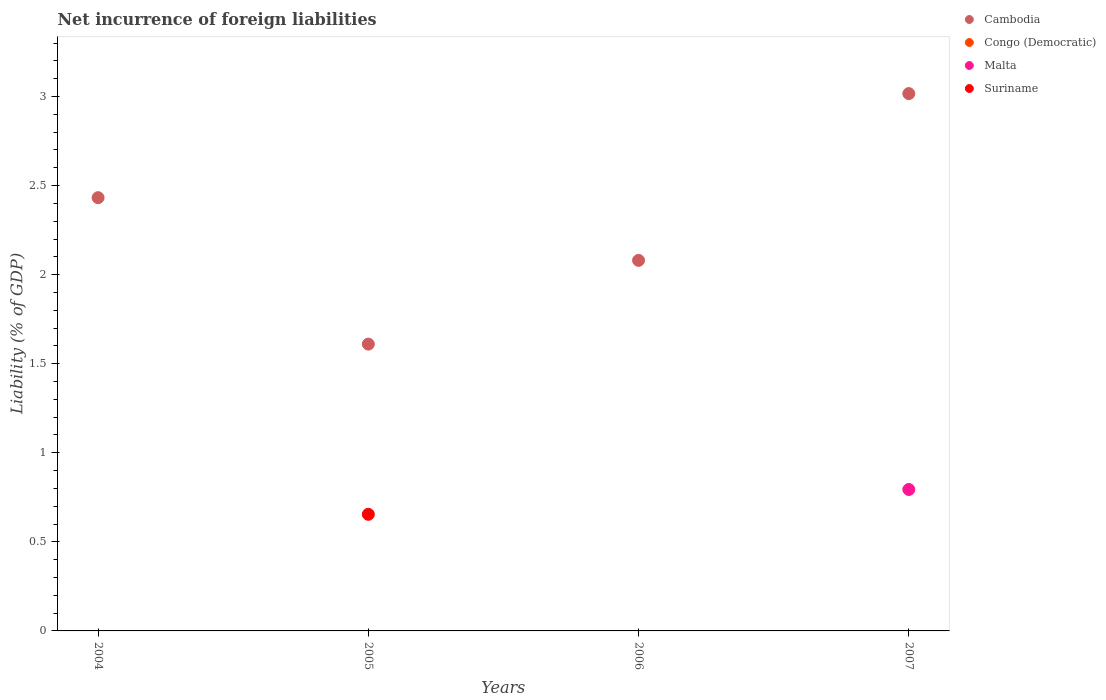What is the net incurrence of foreign liabilities in Cambodia in 2006?
Your answer should be very brief. 2.08. Across all years, what is the maximum net incurrence of foreign liabilities in Cambodia?
Give a very brief answer. 3.02. Across all years, what is the minimum net incurrence of foreign liabilities in Malta?
Give a very brief answer. 0. What is the total net incurrence of foreign liabilities in Suriname in the graph?
Ensure brevity in your answer.  0.65. What is the difference between the net incurrence of foreign liabilities in Cambodia in 2004 and that in 2007?
Your answer should be very brief. -0.58. What is the average net incurrence of foreign liabilities in Cambodia per year?
Make the answer very short. 2.28. In the year 2005, what is the difference between the net incurrence of foreign liabilities in Cambodia and net incurrence of foreign liabilities in Suriname?
Make the answer very short. 0.96. In how many years, is the net incurrence of foreign liabilities in Cambodia greater than 1 %?
Offer a very short reply. 4. What is the ratio of the net incurrence of foreign liabilities in Cambodia in 2004 to that in 2005?
Offer a terse response. 1.51. Is the net incurrence of foreign liabilities in Cambodia in 2005 less than that in 2007?
Give a very brief answer. Yes. What is the difference between the highest and the lowest net incurrence of foreign liabilities in Suriname?
Keep it short and to the point. 0.65. In how many years, is the net incurrence of foreign liabilities in Malta greater than the average net incurrence of foreign liabilities in Malta taken over all years?
Provide a succinct answer. 1. Is it the case that in every year, the sum of the net incurrence of foreign liabilities in Malta and net incurrence of foreign liabilities in Congo (Democratic)  is greater than the sum of net incurrence of foreign liabilities in Suriname and net incurrence of foreign liabilities in Cambodia?
Your answer should be compact. No. Is it the case that in every year, the sum of the net incurrence of foreign liabilities in Cambodia and net incurrence of foreign liabilities in Malta  is greater than the net incurrence of foreign liabilities in Suriname?
Keep it short and to the point. Yes. Is the net incurrence of foreign liabilities in Malta strictly greater than the net incurrence of foreign liabilities in Suriname over the years?
Offer a terse response. No. Is the net incurrence of foreign liabilities in Congo (Democratic) strictly less than the net incurrence of foreign liabilities in Suriname over the years?
Offer a terse response. No. What is the difference between two consecutive major ticks on the Y-axis?
Ensure brevity in your answer.  0.5. Does the graph contain grids?
Your answer should be very brief. No. How are the legend labels stacked?
Offer a very short reply. Vertical. What is the title of the graph?
Offer a very short reply. Net incurrence of foreign liabilities. What is the label or title of the Y-axis?
Give a very brief answer. Liability (% of GDP). What is the Liability (% of GDP) in Cambodia in 2004?
Provide a short and direct response. 2.43. What is the Liability (% of GDP) of Congo (Democratic) in 2004?
Keep it short and to the point. 0. What is the Liability (% of GDP) in Cambodia in 2005?
Keep it short and to the point. 1.61. What is the Liability (% of GDP) in Malta in 2005?
Keep it short and to the point. 0. What is the Liability (% of GDP) in Suriname in 2005?
Your answer should be compact. 0.65. What is the Liability (% of GDP) in Cambodia in 2006?
Provide a short and direct response. 2.08. What is the Liability (% of GDP) in Congo (Democratic) in 2006?
Your answer should be compact. 0. What is the Liability (% of GDP) in Cambodia in 2007?
Provide a succinct answer. 3.02. What is the Liability (% of GDP) of Congo (Democratic) in 2007?
Make the answer very short. 0. What is the Liability (% of GDP) of Malta in 2007?
Offer a terse response. 0.79. What is the Liability (% of GDP) of Suriname in 2007?
Your answer should be very brief. 0. Across all years, what is the maximum Liability (% of GDP) of Cambodia?
Ensure brevity in your answer.  3.02. Across all years, what is the maximum Liability (% of GDP) of Malta?
Make the answer very short. 0.79. Across all years, what is the maximum Liability (% of GDP) in Suriname?
Offer a terse response. 0.65. Across all years, what is the minimum Liability (% of GDP) of Cambodia?
Keep it short and to the point. 1.61. Across all years, what is the minimum Liability (% of GDP) of Malta?
Provide a short and direct response. 0. What is the total Liability (% of GDP) in Cambodia in the graph?
Your answer should be very brief. 9.14. What is the total Liability (% of GDP) of Malta in the graph?
Offer a very short reply. 0.79. What is the total Liability (% of GDP) of Suriname in the graph?
Provide a short and direct response. 0.65. What is the difference between the Liability (% of GDP) of Cambodia in 2004 and that in 2005?
Give a very brief answer. 0.82. What is the difference between the Liability (% of GDP) of Cambodia in 2004 and that in 2006?
Ensure brevity in your answer.  0.35. What is the difference between the Liability (% of GDP) of Cambodia in 2004 and that in 2007?
Your answer should be compact. -0.58. What is the difference between the Liability (% of GDP) in Cambodia in 2005 and that in 2006?
Ensure brevity in your answer.  -0.47. What is the difference between the Liability (% of GDP) of Cambodia in 2005 and that in 2007?
Give a very brief answer. -1.41. What is the difference between the Liability (% of GDP) of Cambodia in 2006 and that in 2007?
Provide a short and direct response. -0.94. What is the difference between the Liability (% of GDP) of Cambodia in 2004 and the Liability (% of GDP) of Suriname in 2005?
Offer a very short reply. 1.78. What is the difference between the Liability (% of GDP) in Cambodia in 2004 and the Liability (% of GDP) in Malta in 2007?
Provide a succinct answer. 1.64. What is the difference between the Liability (% of GDP) in Cambodia in 2005 and the Liability (% of GDP) in Malta in 2007?
Give a very brief answer. 0.82. What is the difference between the Liability (% of GDP) in Cambodia in 2006 and the Liability (% of GDP) in Malta in 2007?
Give a very brief answer. 1.29. What is the average Liability (% of GDP) of Cambodia per year?
Your response must be concise. 2.28. What is the average Liability (% of GDP) of Malta per year?
Ensure brevity in your answer.  0.2. What is the average Liability (% of GDP) in Suriname per year?
Your answer should be compact. 0.16. In the year 2005, what is the difference between the Liability (% of GDP) in Cambodia and Liability (% of GDP) in Suriname?
Make the answer very short. 0.96. In the year 2007, what is the difference between the Liability (% of GDP) of Cambodia and Liability (% of GDP) of Malta?
Keep it short and to the point. 2.22. What is the ratio of the Liability (% of GDP) in Cambodia in 2004 to that in 2005?
Ensure brevity in your answer.  1.51. What is the ratio of the Liability (% of GDP) in Cambodia in 2004 to that in 2006?
Make the answer very short. 1.17. What is the ratio of the Liability (% of GDP) in Cambodia in 2004 to that in 2007?
Make the answer very short. 0.81. What is the ratio of the Liability (% of GDP) in Cambodia in 2005 to that in 2006?
Offer a very short reply. 0.77. What is the ratio of the Liability (% of GDP) of Cambodia in 2005 to that in 2007?
Provide a short and direct response. 0.53. What is the ratio of the Liability (% of GDP) of Cambodia in 2006 to that in 2007?
Your answer should be very brief. 0.69. What is the difference between the highest and the second highest Liability (% of GDP) of Cambodia?
Make the answer very short. 0.58. What is the difference between the highest and the lowest Liability (% of GDP) in Cambodia?
Provide a short and direct response. 1.41. What is the difference between the highest and the lowest Liability (% of GDP) of Malta?
Make the answer very short. 0.79. What is the difference between the highest and the lowest Liability (% of GDP) in Suriname?
Offer a terse response. 0.65. 